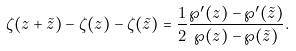Convert formula to latex. <formula><loc_0><loc_0><loc_500><loc_500>\zeta ( z + \tilde { z } ) - \zeta ( z ) - \zeta ( \tilde { z } ) = \frac { 1 } { 2 } \frac { \wp ^ { \prime } ( z ) - \wp ^ { \prime } ( \tilde { z } ) } { \wp ( z ) - \wp ( \tilde { z } ) } .</formula> 